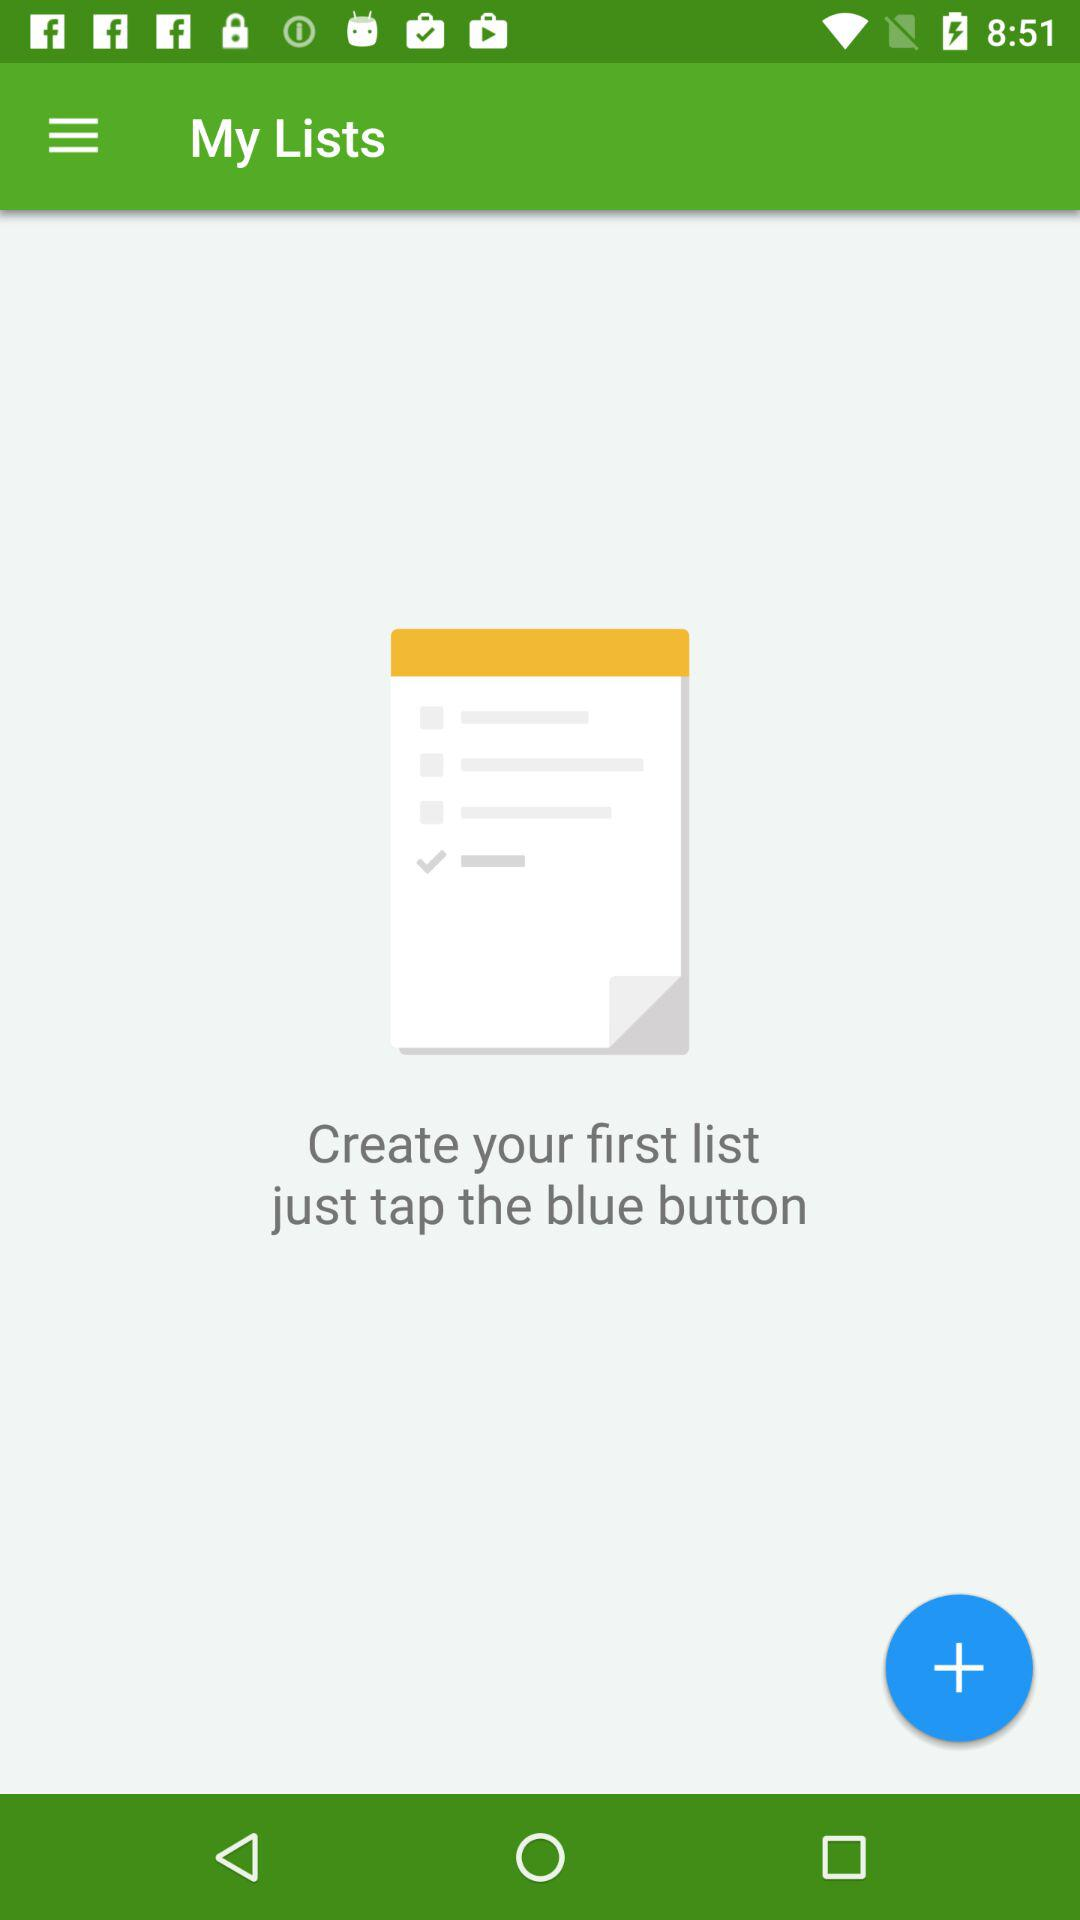What is the application name? The application name is "My Lists". 